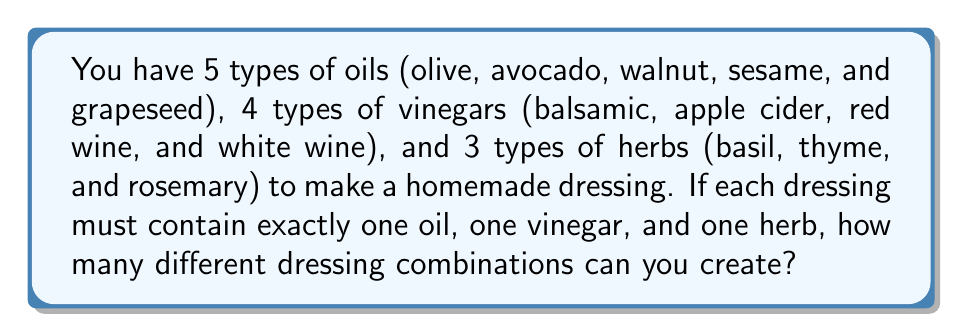Could you help me with this problem? Let's approach this step-by-step using the multiplication principle of counting:

1) For each dressing, we need to choose:
   - One oil out of 5 options
   - One vinegar out of 4 options
   - One herb out of 3 options

2) The multiplication principle states that if we have a series of choices, where:
   - There are $m$ ways of doing something,
   - $n$ ways of doing another thing,
   - $p$ ways of doing a third thing,
   Then there are $m \times n \times p$ ways to do all three things.

3) In this case:
   - There are 5 ways to choose an oil
   - 4 ways to choose a vinegar
   - 3 ways to choose an herb

4) Therefore, the total number of possible dressing combinations is:

   $$ 5 \times 4 \times 3 = 60 $$

Thus, you can create 60 different dressing combinations using these ingredients.
Answer: 60 